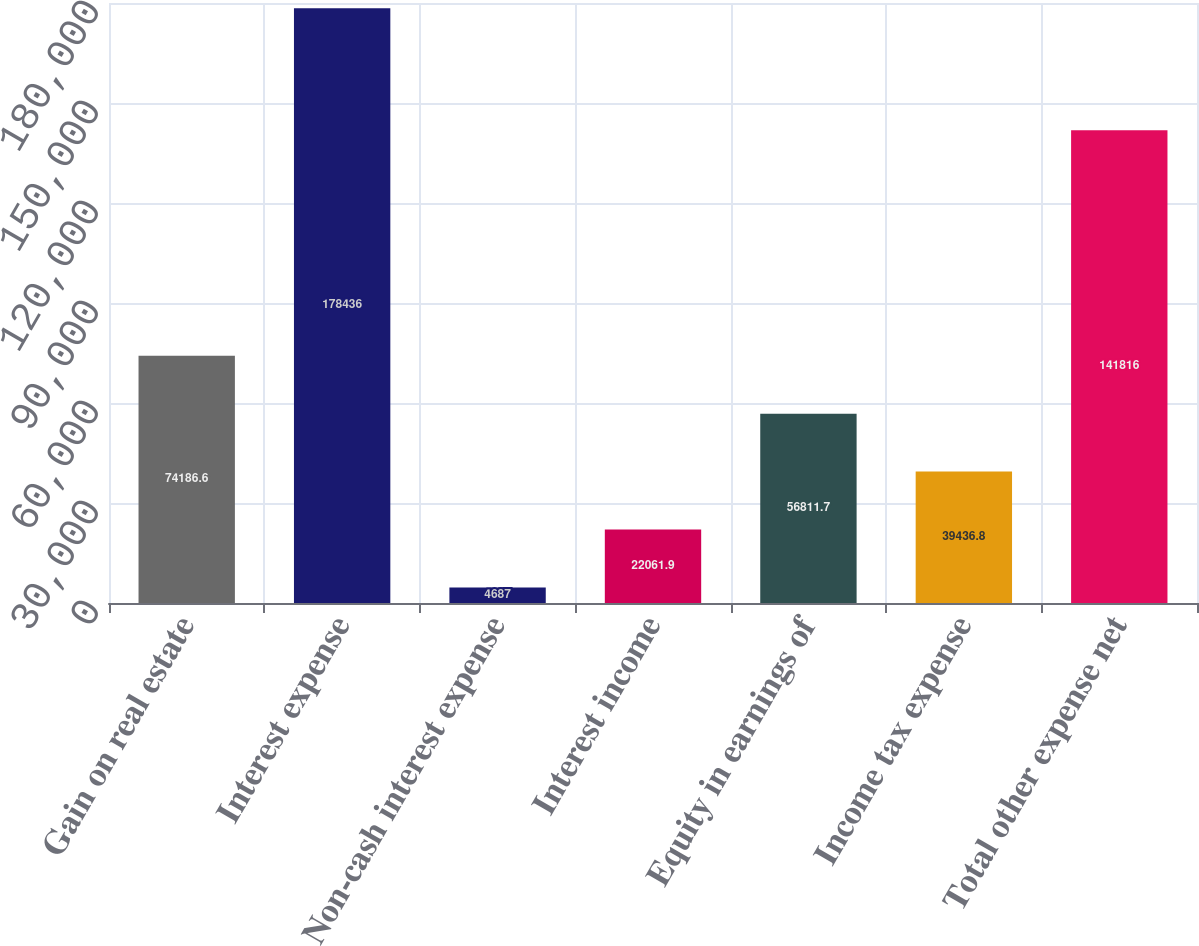<chart> <loc_0><loc_0><loc_500><loc_500><bar_chart><fcel>Gain on real estate<fcel>Interest expense<fcel>Non-cash interest expense<fcel>Interest income<fcel>Equity in earnings of<fcel>Income tax expense<fcel>Total other expense net<nl><fcel>74186.6<fcel>178436<fcel>4687<fcel>22061.9<fcel>56811.7<fcel>39436.8<fcel>141816<nl></chart> 